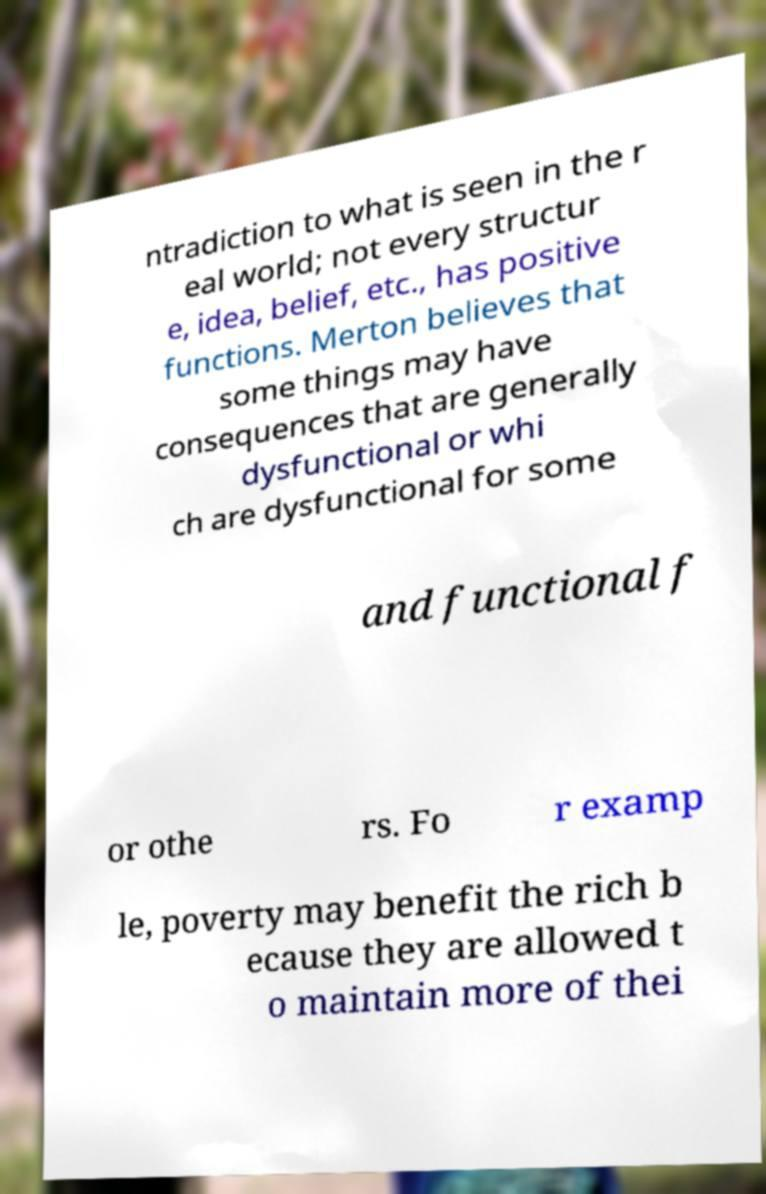Could you extract and type out the text from this image? ntradiction to what is seen in the r eal world; not every structur e, idea, belief, etc., has positive functions. Merton believes that some things may have consequences that are generally dysfunctional or whi ch are dysfunctional for some and functional f or othe rs. Fo r examp le, poverty may benefit the rich b ecause they are allowed t o maintain more of thei 